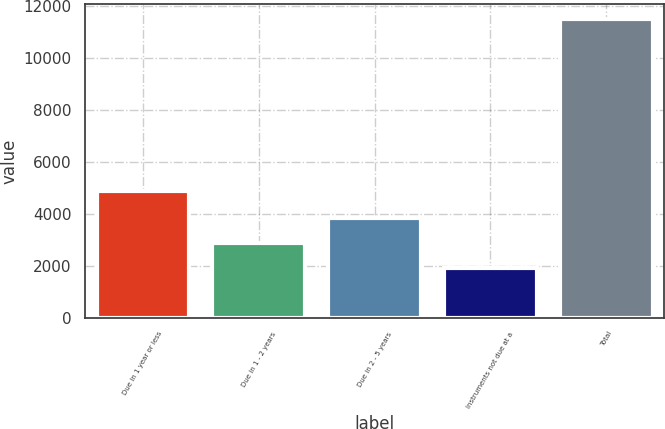Convert chart to OTSL. <chart><loc_0><loc_0><loc_500><loc_500><bar_chart><fcel>Due in 1 year or less<fcel>Due in 1 - 2 years<fcel>Due in 2 - 5 years<fcel>Instruments not due at a<fcel>Total<nl><fcel>4866<fcel>2878.2<fcel>3836.4<fcel>1920<fcel>11502<nl></chart> 